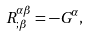<formula> <loc_0><loc_0><loc_500><loc_500>R ^ { \alpha \beta } _ { ; \beta } = - G ^ { \alpha } ,</formula> 